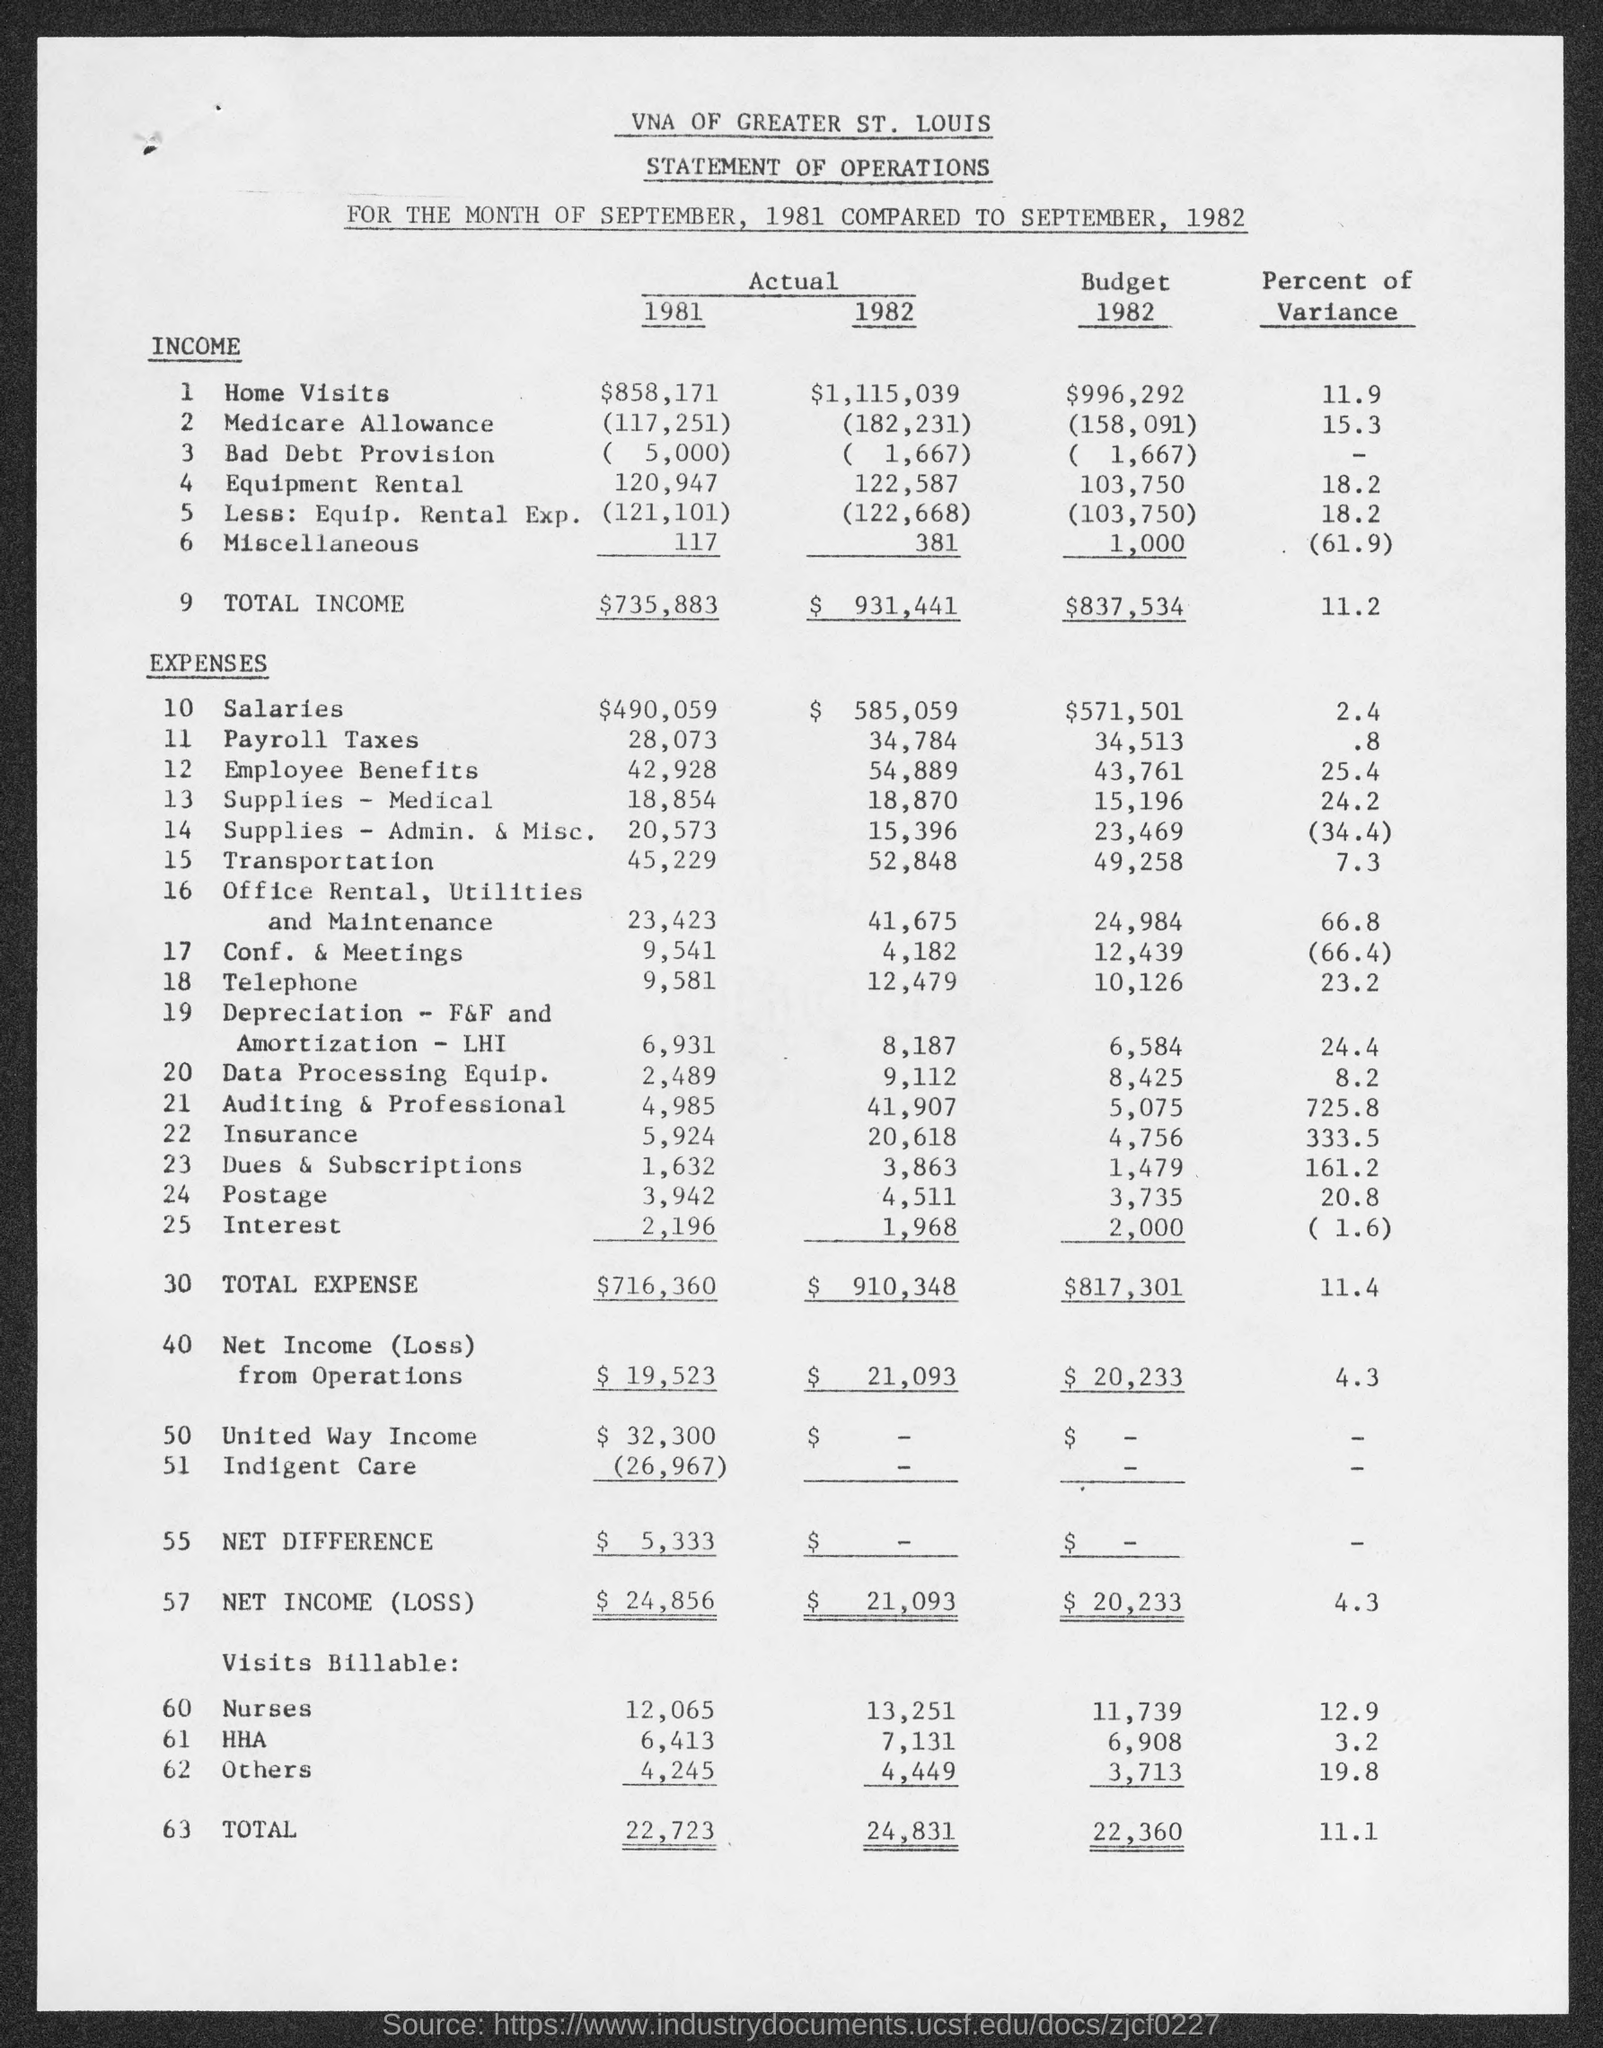What is the actual income for home visits for 1981?
Make the answer very short. $858,171. What is the actual income for home visits for 1982?
Your answer should be very brief. $1,115,039. What is the actual income for medicare allowance for 1981?
Your response must be concise. (117,251). What is the actual income for medicare allowance for 1982?
Offer a very short reply. 182,231. What is the actual income for bad debt provision for 1981?
Offer a terse response. (5,000). What is the actual income for bad debt provision for 1982?
Keep it short and to the point. ( 1,667). What is the actual income for equipment rental for 1981?
Provide a succinct answer. 120,947. What is the actual income for equipment rental for 1982?
Provide a succinct answer. 122,587. What is the actual income for Miscellaneous for 1981?
Provide a short and direct response. 117. What is the actual income for Miscellaneous for 1982?
Ensure brevity in your answer.  381. 